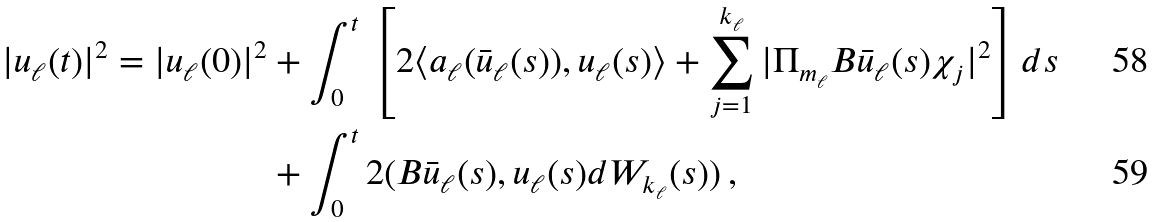<formula> <loc_0><loc_0><loc_500><loc_500>| u _ { \ell } ( t ) | ^ { 2 } = | u _ { \ell } ( 0 ) | ^ { 2 } & + \int _ { 0 } ^ { t } \, \left [ 2 \langle a _ { \ell } ( \bar { u } _ { \ell } ( s ) ) , u _ { \ell } ( s ) \rangle + \sum _ { j = 1 } ^ { k _ { \ell } } | \Pi _ { m _ { \ell } } B \bar { u } _ { \ell } ( s ) \chi _ { j } | ^ { 2 } \right ] d s \\ & + \int _ { 0 } ^ { t } 2 ( B \bar { u } _ { \ell } ( s ) , u _ { \ell } ( s ) d W _ { k _ { \ell } } ( s ) ) \, ,</formula> 